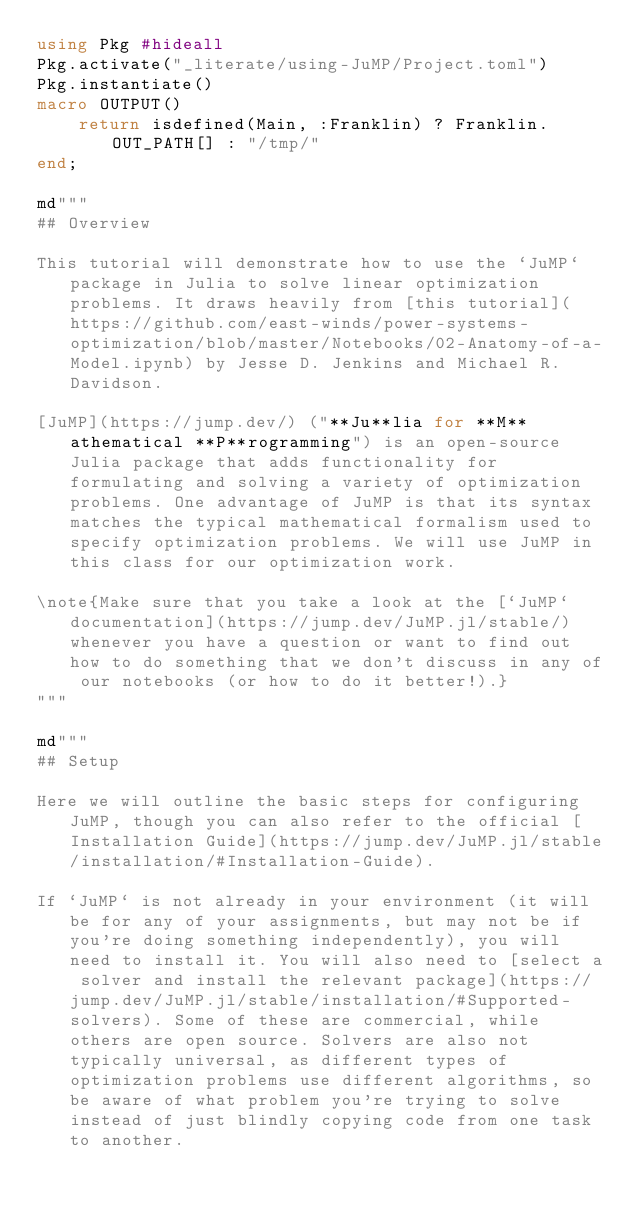<code> <loc_0><loc_0><loc_500><loc_500><_Julia_>using Pkg #hideall
Pkg.activate("_literate/using-JuMP/Project.toml")
Pkg.instantiate()
macro OUTPUT()
    return isdefined(Main, :Franklin) ? Franklin.OUT_PATH[] : "/tmp/"
end;

md"""
## Overview

This tutorial will demonstrate how to use the `JuMP` package in Julia to solve linear optimization problems. It draws heavily from [this tutorial](https://github.com/east-winds/power-systems-optimization/blob/master/Notebooks/02-Anatomy-of-a-Model.ipynb) by Jesse D. Jenkins and Michael R. Davidson.

[JuMP](https://jump.dev/) ("**Ju**lia for **M**athematical **P**rogramming") is an open-source Julia package that adds functionality for formulating and solving a variety of optimization problems. One advantage of JuMP is that its syntax matches the typical mathematical formalism used to specify optimization problems. We will use JuMP in this class for our optimization work.

\note{Make sure that you take a look at the [`JuMP` documentation](https://jump.dev/JuMP.jl/stable/) whenever you have a question or want to find out how to do something that we don't discuss in any of our notebooks (or how to do it better!).}
"""

md"""
## Setup

Here we will outline the basic steps for configuring JuMP, though you can also refer to the official [Installation Guide](https://jump.dev/JuMP.jl/stable/installation/#Installation-Guide).

If `JuMP` is not already in your environment (it will be for any of your assignments, but may not be if you're doing something independently), you will need to install it. You will also need to [select a solver and install the relevant package](https://jump.dev/JuMP.jl/stable/installation/#Supported-solvers). Some of these are commercial, while others are open source. Solvers are also not typically universal, as different types of optimization problems use different algorithms, so be aware of what problem you're trying to solve instead of just blindly copying code from one task to another. 
</code> 